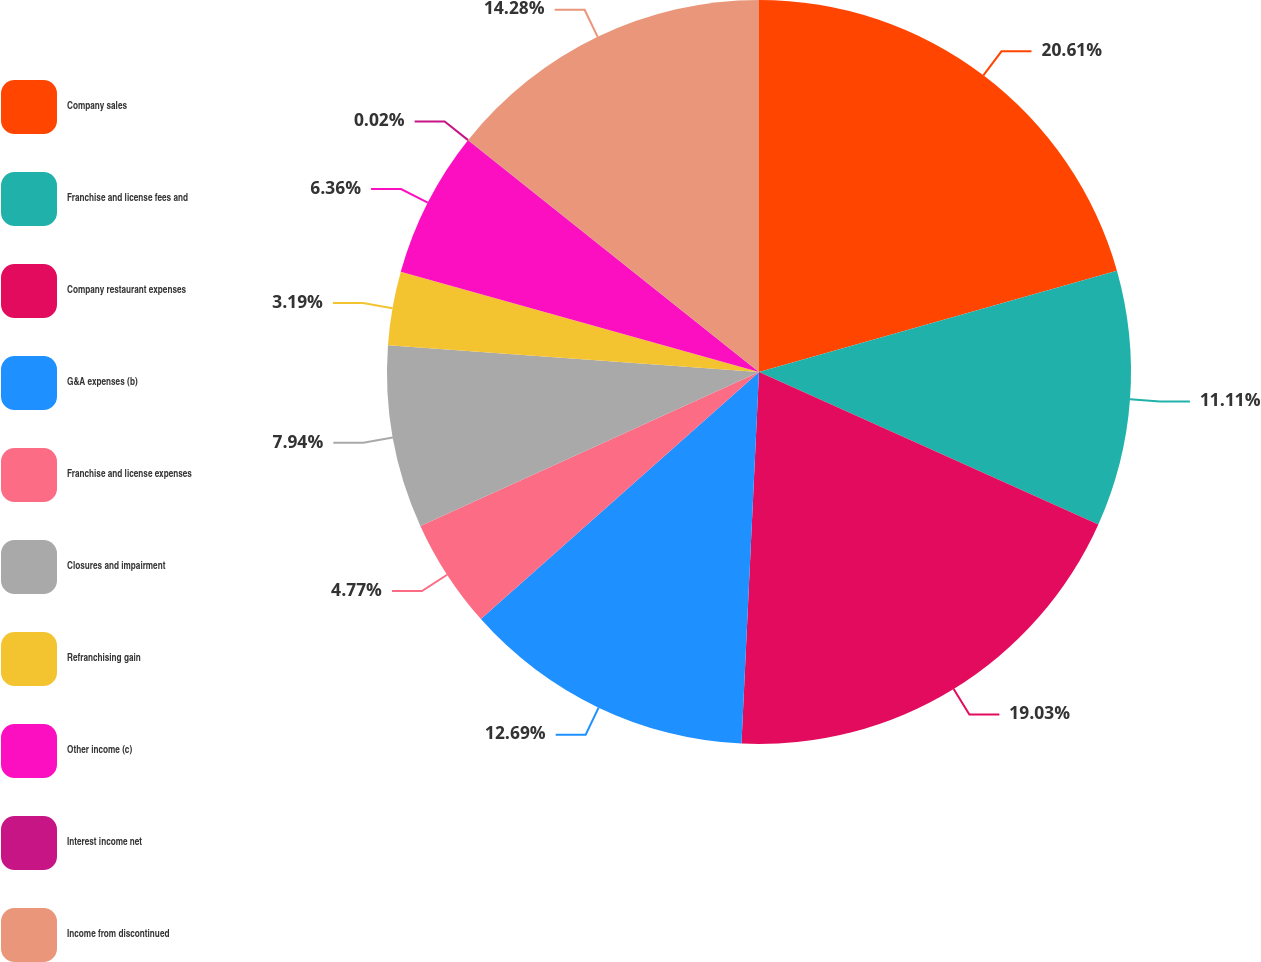<chart> <loc_0><loc_0><loc_500><loc_500><pie_chart><fcel>Company sales<fcel>Franchise and license fees and<fcel>Company restaurant expenses<fcel>G&A expenses (b)<fcel>Franchise and license expenses<fcel>Closures and impairment<fcel>Refranchising gain<fcel>Other income (c)<fcel>Interest income net<fcel>Income from discontinued<nl><fcel>20.61%<fcel>11.11%<fcel>19.03%<fcel>12.69%<fcel>4.77%<fcel>7.94%<fcel>3.19%<fcel>6.36%<fcel>0.02%<fcel>14.28%<nl></chart> 